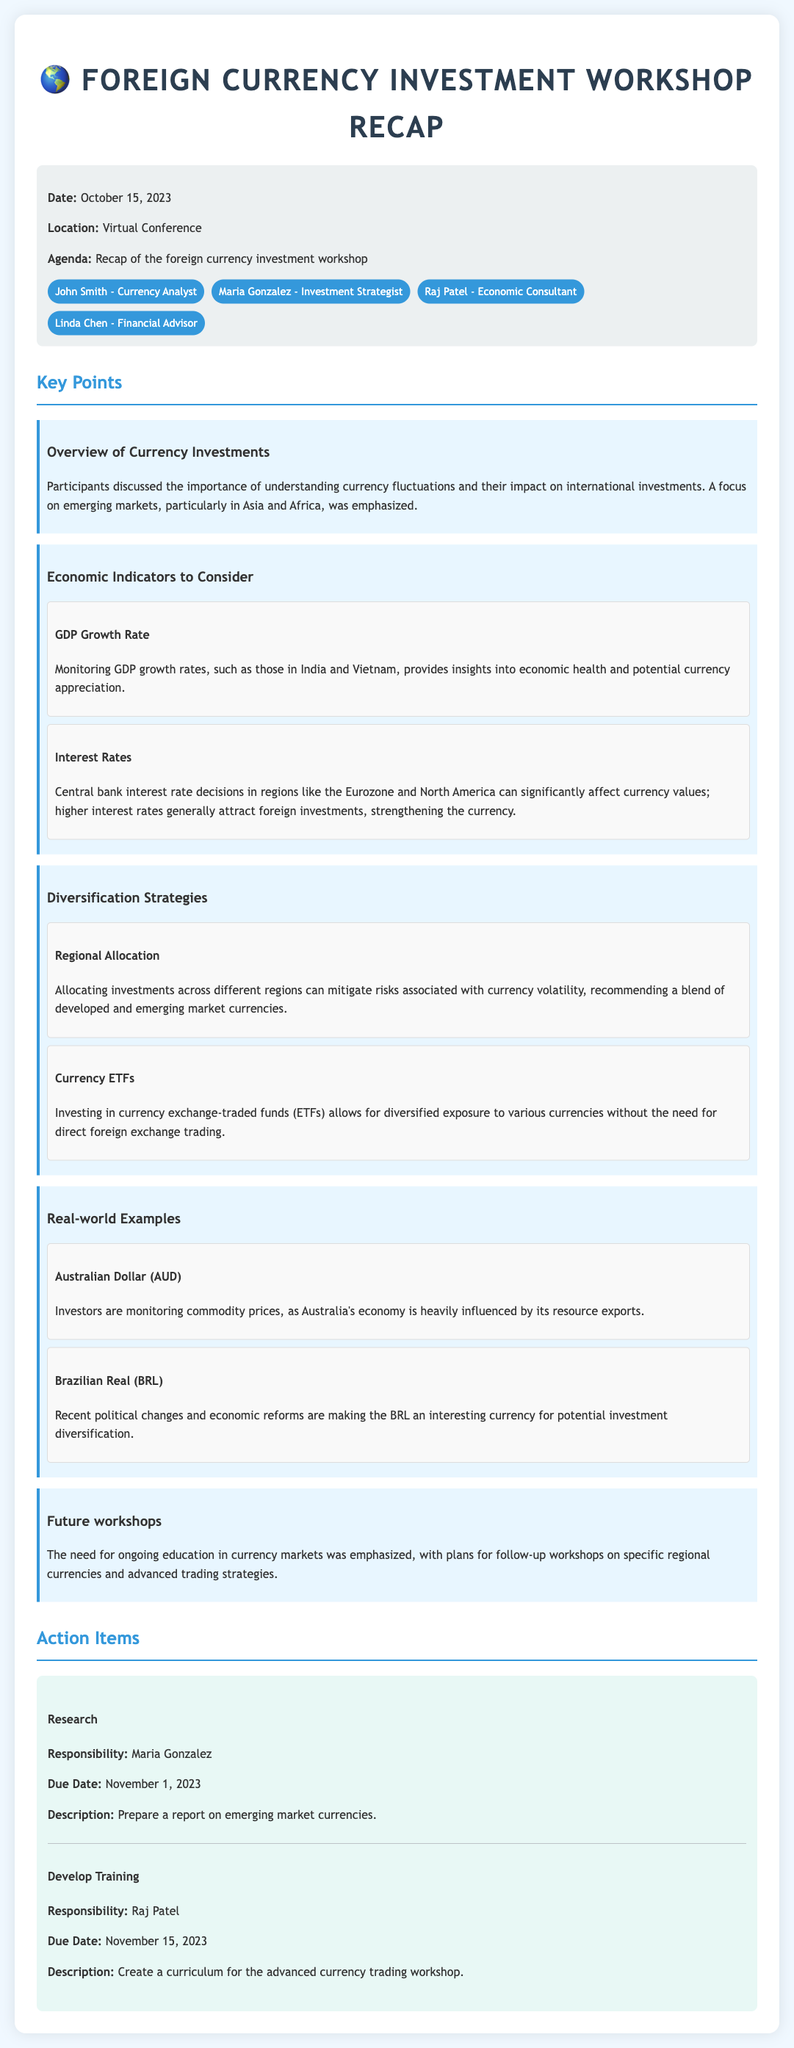What was the date of the workshop? The document states the date of the workshop as October 15, 2023.
Answer: October 15, 2023 Who is responsible for preparing the report on emerging market currencies? The document lists Maria Gonzalez as the individual responsible for this action item.
Answer: Maria Gonzalez What economic indicator is monitored for insights into economic health? The document mentions GDP growth rates as a crucial economic indicator to monitor.
Answer: GDP growth rates Which currency ETF strategy is mentioned in the recap? The document refers to investing in currency exchange-traded funds as a strategy for diversified exposure.
Answer: Currency ETFs What is the due date for the training curriculum development? The due date for this action item is specified as November 15, 2023.
Answer: November 15, 2023 How do higher interest rates generally affect currency values? According to the document, higher interest rates generally attract foreign investments, strengthening the currency.
Answer: Strengthening the currency What type of examples are provided in relation to currency investments? The document includes real-world examples related to specific currencies like the Australian Dollar and Brazilian Real.
Answer: Real-world examples What future plans were discussed regarding the workshops? The document notes that the need for ongoing education in currency markets was emphasized, with plans for follow-up workshops.
Answer: Follow-up workshops 